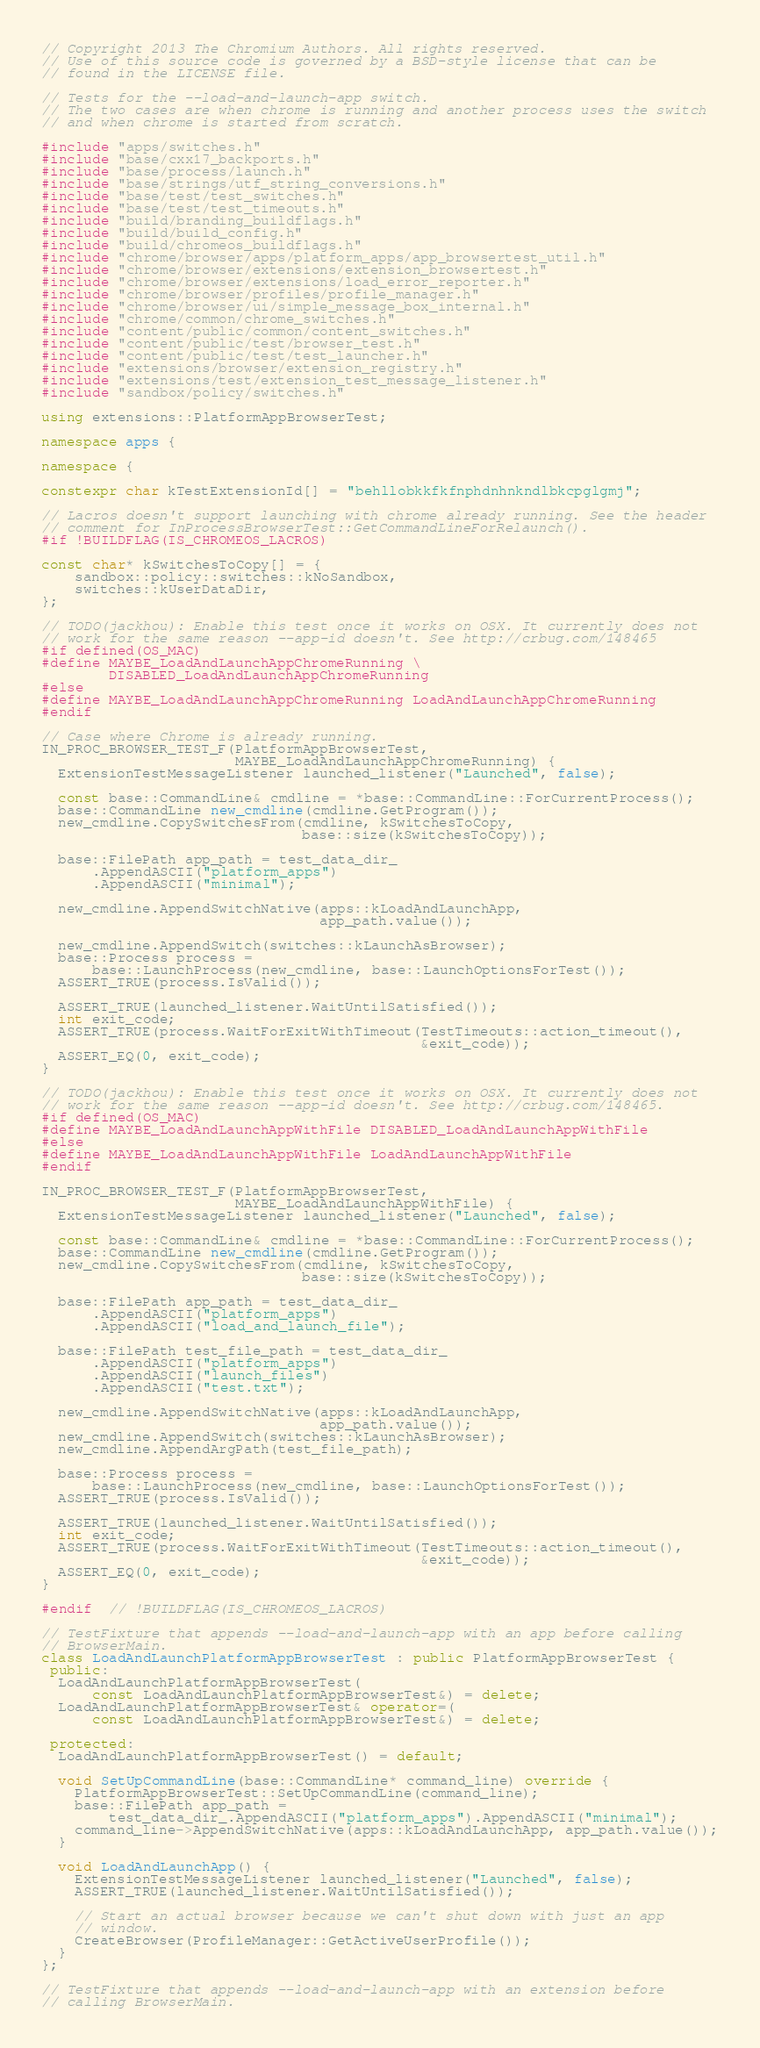Convert code to text. <code><loc_0><loc_0><loc_500><loc_500><_C++_>// Copyright 2013 The Chromium Authors. All rights reserved.
// Use of this source code is governed by a BSD-style license that can be
// found in the LICENSE file.

// Tests for the --load-and-launch-app switch.
// The two cases are when chrome is running and another process uses the switch
// and when chrome is started from scratch.

#include "apps/switches.h"
#include "base/cxx17_backports.h"
#include "base/process/launch.h"
#include "base/strings/utf_string_conversions.h"
#include "base/test/test_switches.h"
#include "base/test/test_timeouts.h"
#include "build/branding_buildflags.h"
#include "build/build_config.h"
#include "build/chromeos_buildflags.h"
#include "chrome/browser/apps/platform_apps/app_browsertest_util.h"
#include "chrome/browser/extensions/extension_browsertest.h"
#include "chrome/browser/extensions/load_error_reporter.h"
#include "chrome/browser/profiles/profile_manager.h"
#include "chrome/browser/ui/simple_message_box_internal.h"
#include "chrome/common/chrome_switches.h"
#include "content/public/common/content_switches.h"
#include "content/public/test/browser_test.h"
#include "content/public/test/test_launcher.h"
#include "extensions/browser/extension_registry.h"
#include "extensions/test/extension_test_message_listener.h"
#include "sandbox/policy/switches.h"

using extensions::PlatformAppBrowserTest;

namespace apps {

namespace {

constexpr char kTestExtensionId[] = "behllobkkfkfnphdnhnkndlbkcpglgmj";

// Lacros doesn't support launching with chrome already running. See the header
// comment for InProcessBrowserTest::GetCommandLineForRelaunch().
#if !BUILDFLAG(IS_CHROMEOS_LACROS)

const char* kSwitchesToCopy[] = {
    sandbox::policy::switches::kNoSandbox,
    switches::kUserDataDir,
};

// TODO(jackhou): Enable this test once it works on OSX. It currently does not
// work for the same reason --app-id doesn't. See http://crbug.com/148465
#if defined(OS_MAC)
#define MAYBE_LoadAndLaunchAppChromeRunning \
        DISABLED_LoadAndLaunchAppChromeRunning
#else
#define MAYBE_LoadAndLaunchAppChromeRunning LoadAndLaunchAppChromeRunning
#endif

// Case where Chrome is already running.
IN_PROC_BROWSER_TEST_F(PlatformAppBrowserTest,
                       MAYBE_LoadAndLaunchAppChromeRunning) {
  ExtensionTestMessageListener launched_listener("Launched", false);

  const base::CommandLine& cmdline = *base::CommandLine::ForCurrentProcess();
  base::CommandLine new_cmdline(cmdline.GetProgram());
  new_cmdline.CopySwitchesFrom(cmdline, kSwitchesToCopy,
                               base::size(kSwitchesToCopy));

  base::FilePath app_path = test_data_dir_
      .AppendASCII("platform_apps")
      .AppendASCII("minimal");

  new_cmdline.AppendSwitchNative(apps::kLoadAndLaunchApp,
                                 app_path.value());

  new_cmdline.AppendSwitch(switches::kLaunchAsBrowser);
  base::Process process =
      base::LaunchProcess(new_cmdline, base::LaunchOptionsForTest());
  ASSERT_TRUE(process.IsValid());

  ASSERT_TRUE(launched_listener.WaitUntilSatisfied());
  int exit_code;
  ASSERT_TRUE(process.WaitForExitWithTimeout(TestTimeouts::action_timeout(),
                                             &exit_code));
  ASSERT_EQ(0, exit_code);
}

// TODO(jackhou): Enable this test once it works on OSX. It currently does not
// work for the same reason --app-id doesn't. See http://crbug.com/148465.
#if defined(OS_MAC)
#define MAYBE_LoadAndLaunchAppWithFile DISABLED_LoadAndLaunchAppWithFile
#else
#define MAYBE_LoadAndLaunchAppWithFile LoadAndLaunchAppWithFile
#endif

IN_PROC_BROWSER_TEST_F(PlatformAppBrowserTest,
                       MAYBE_LoadAndLaunchAppWithFile) {
  ExtensionTestMessageListener launched_listener("Launched", false);

  const base::CommandLine& cmdline = *base::CommandLine::ForCurrentProcess();
  base::CommandLine new_cmdline(cmdline.GetProgram());
  new_cmdline.CopySwitchesFrom(cmdline, kSwitchesToCopy,
                               base::size(kSwitchesToCopy));

  base::FilePath app_path = test_data_dir_
      .AppendASCII("platform_apps")
      .AppendASCII("load_and_launch_file");

  base::FilePath test_file_path = test_data_dir_
      .AppendASCII("platform_apps")
      .AppendASCII("launch_files")
      .AppendASCII("test.txt");

  new_cmdline.AppendSwitchNative(apps::kLoadAndLaunchApp,
                                 app_path.value());
  new_cmdline.AppendSwitch(switches::kLaunchAsBrowser);
  new_cmdline.AppendArgPath(test_file_path);

  base::Process process =
      base::LaunchProcess(new_cmdline, base::LaunchOptionsForTest());
  ASSERT_TRUE(process.IsValid());

  ASSERT_TRUE(launched_listener.WaitUntilSatisfied());
  int exit_code;
  ASSERT_TRUE(process.WaitForExitWithTimeout(TestTimeouts::action_timeout(),
                                             &exit_code));
  ASSERT_EQ(0, exit_code);
}

#endif  // !BUILDFLAG(IS_CHROMEOS_LACROS)

// TestFixture that appends --load-and-launch-app with an app before calling
// BrowserMain.
class LoadAndLaunchPlatformAppBrowserTest : public PlatformAppBrowserTest {
 public:
  LoadAndLaunchPlatformAppBrowserTest(
      const LoadAndLaunchPlatformAppBrowserTest&) = delete;
  LoadAndLaunchPlatformAppBrowserTest& operator=(
      const LoadAndLaunchPlatformAppBrowserTest&) = delete;

 protected:
  LoadAndLaunchPlatformAppBrowserTest() = default;

  void SetUpCommandLine(base::CommandLine* command_line) override {
    PlatformAppBrowserTest::SetUpCommandLine(command_line);
    base::FilePath app_path =
        test_data_dir_.AppendASCII("platform_apps").AppendASCII("minimal");
    command_line->AppendSwitchNative(apps::kLoadAndLaunchApp, app_path.value());
  }

  void LoadAndLaunchApp() {
    ExtensionTestMessageListener launched_listener("Launched", false);
    ASSERT_TRUE(launched_listener.WaitUntilSatisfied());

    // Start an actual browser because we can't shut down with just an app
    // window.
    CreateBrowser(ProfileManager::GetActiveUserProfile());
  }
};

// TestFixture that appends --load-and-launch-app with an extension before
// calling BrowserMain.</code> 